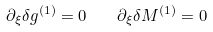Convert formula to latex. <formula><loc_0><loc_0><loc_500><loc_500>\partial _ { \xi } \delta g ^ { ( 1 ) } = 0 \quad \partial _ { \xi } \delta M ^ { ( 1 ) } = 0</formula> 